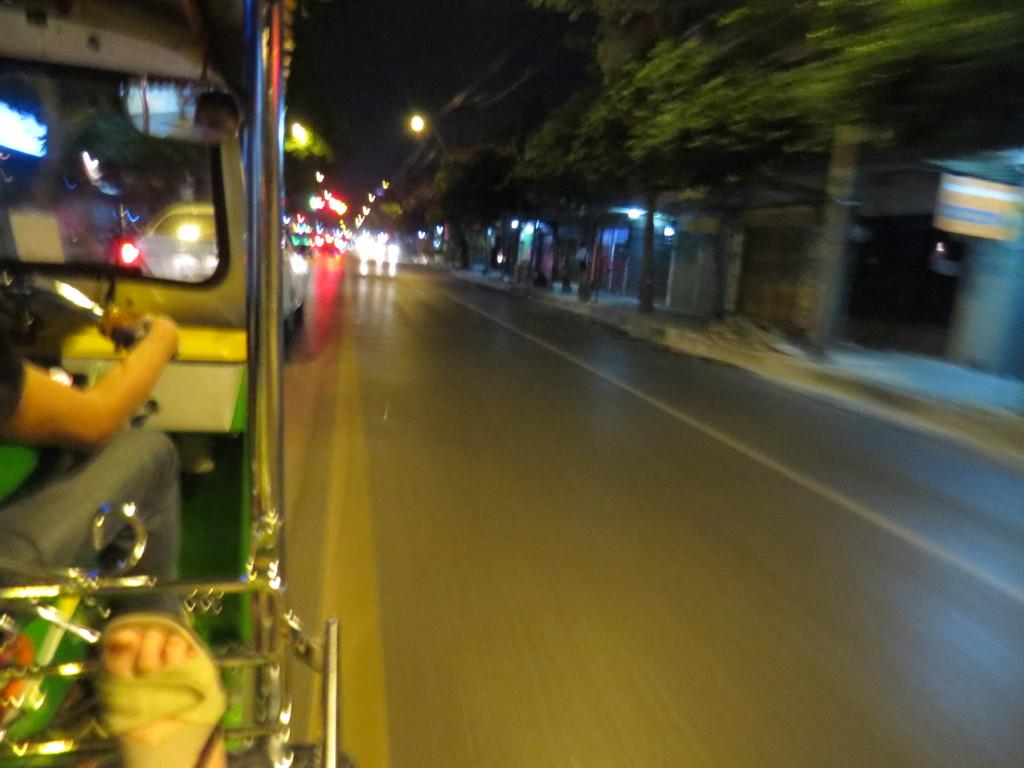What can be seen on the left side of the image? There is a vehicle on the left side of the image. Who is associated with the vehicle in the image? A person is associated with the vehicle in the image. What is the setting of the image? There is a road and shops in the image, suggesting an urban or commercial area. What type of vegetation is present in the image? Trees are present in the image. What can be seen in the image that might provide illumination? Lights are visible in the image. What type of thread is being used to sew the person's interest in the image? There is no thread or sewing activity present in the image. The person is associated with a vehicle, and there are no references to sewing or interests in the provided facts. 